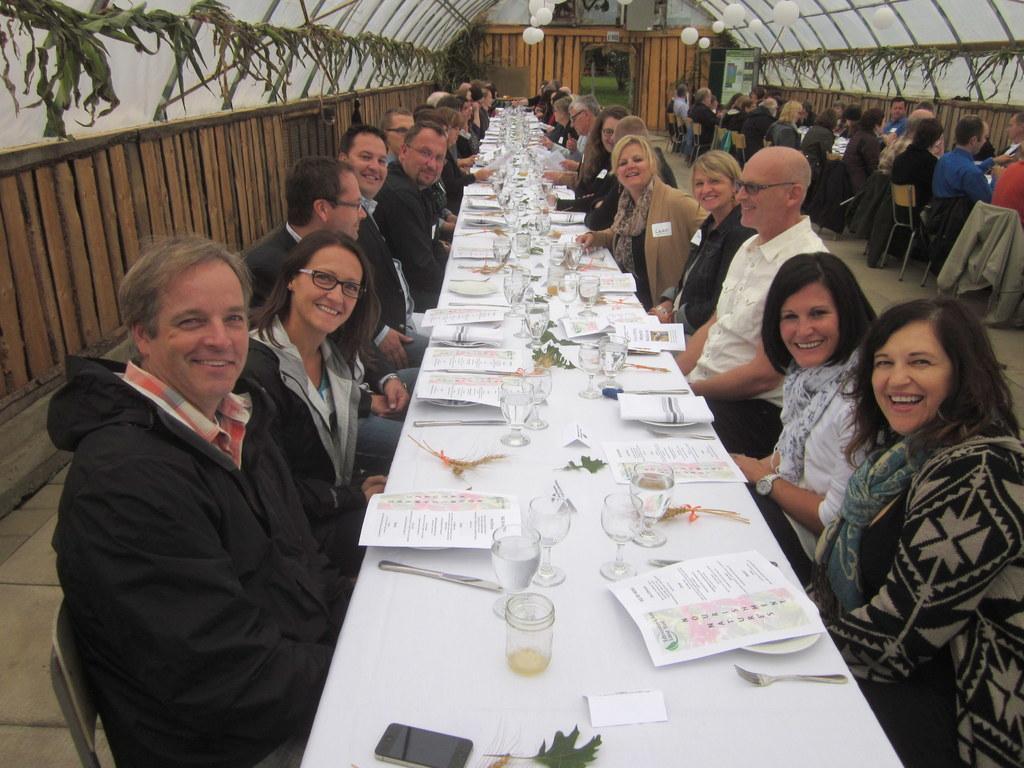Describe this image in one or two sentences. There are many people sitting around the table. On the table there are papers, glasses, knife, mobile phone, leaf, plates. Behind them there is a wooden wall. There are lamps on the ceiling. And there is an entrance. On the right side also some people are sitting around the table. 